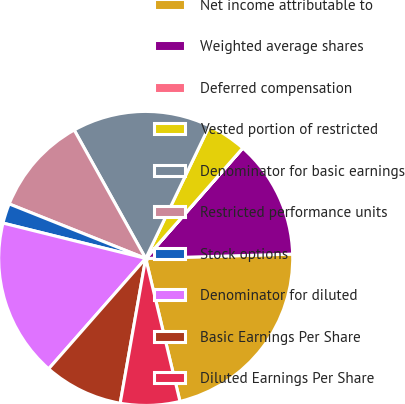<chart> <loc_0><loc_0><loc_500><loc_500><pie_chart><fcel>Net income attributable to<fcel>Weighted average shares<fcel>Deferred compensation<fcel>Vested portion of restricted<fcel>Denominator for basic earnings<fcel>Restricted performance units<fcel>Stock options<fcel>Denominator for diluted<fcel>Basic Earnings Per Share<fcel>Diluted Earnings Per Share<nl><fcel>21.73%<fcel>13.04%<fcel>0.01%<fcel>4.35%<fcel>15.21%<fcel>10.87%<fcel>2.18%<fcel>17.39%<fcel>8.7%<fcel>6.52%<nl></chart> 